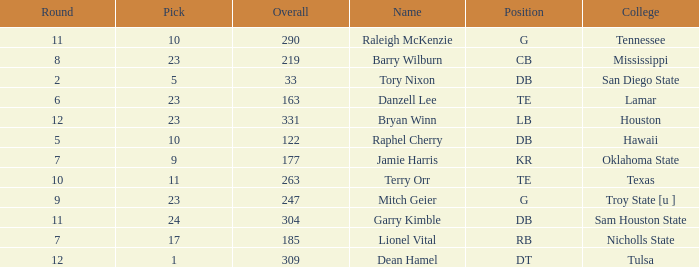Which Overall is the highest one that has a Name of raleigh mckenzie, and a Pick larger than 10? None. Give me the full table as a dictionary. {'header': ['Round', 'Pick', 'Overall', 'Name', 'Position', 'College'], 'rows': [['11', '10', '290', 'Raleigh McKenzie', 'G', 'Tennessee'], ['8', '23', '219', 'Barry Wilburn', 'CB', 'Mississippi'], ['2', '5', '33', 'Tory Nixon', 'DB', 'San Diego State'], ['6', '23', '163', 'Danzell Lee', 'TE', 'Lamar'], ['12', '23', '331', 'Bryan Winn', 'LB', 'Houston'], ['5', '10', '122', 'Raphel Cherry', 'DB', 'Hawaii'], ['7', '9', '177', 'Jamie Harris', 'KR', 'Oklahoma State'], ['10', '11', '263', 'Terry Orr', 'TE', 'Texas'], ['9', '23', '247', 'Mitch Geier', 'G', 'Troy State [u ]'], ['11', '24', '304', 'Garry Kimble', 'DB', 'Sam Houston State'], ['7', '17', '185', 'Lionel Vital', 'RB', 'Nicholls State'], ['12', '1', '309', 'Dean Hamel', 'DT', 'Tulsa']]} 